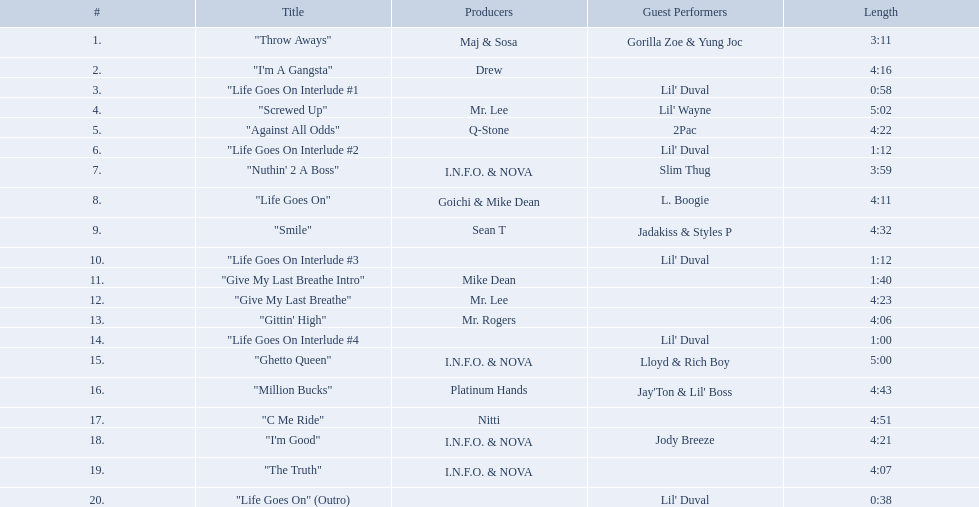What are the song lengths of all the songs on the album? 3:11, 4:16, 0:58, 5:02, 4:22, 1:12, 3:59, 4:11, 4:32, 1:12, 1:40, 4:23, 4:06, 1:00, 5:00, 4:43, 4:51, 4:21, 4:07, 0:38. Which is the longest of these? 5:02. Which tunes last longer than 4.00? "I'm A Gangsta", "Screwed Up", "Against All Odds", "Life Goes On", "Smile", "Give My Last Breathe", "Gittin' High", "Ghetto Queen", "Million Bucks", "C Me Ride", "I'm Good", "The Truth". Of those, which tunes have a duration surpassing 4.30? "Screwed Up", "Smile", "Ghetto Queen", "Million Bucks", "C Me Ride". Of those, which tunes are 5.00 or lengthier? "Screwed Up", "Ghetto Queen". Among them, which one is the most extended? "Screwed Up". How lengthy is that tune? 5:02. Which songs have a duration greater than 4.00? "I'm A Gangsta", "Screwed Up", "Against All Odds", "Life Goes On", "Smile", "Give My Last Breathe", "Gittin' High", "Ghetto Queen", "Million Bucks", "C Me Ride", "I'm Good", "The Truth". Among them, which songs exceed 4.30? "Screwed Up", "Smile", "Ghetto Queen", "Million Bucks", "C Me Ride". Among those, which songs are 5.00 or more? "Screwed Up", "Ghetto Queen". Out of those, which one has the maximum length? "Screwed Up". What is the duration of that song? 5:02. What songs are featured on the album life goes on by trae? "Throw Aways", "I'm A Gangsta", "Life Goes On Interlude #1, "Screwed Up", "Against All Odds", "Life Goes On Interlude #2, "Nuthin' 2 A Boss", "Life Goes On", "Smile", "Life Goes On Interlude #3, "Give My Last Breathe Intro", "Give My Last Breathe", "Gittin' High", "Life Goes On Interlude #4, "Ghetto Queen", "Million Bucks", "C Me Ride", "I'm Good", "The Truth", "Life Goes On" (Outro). Which of these tracks have a duration of at least 5 minutes? "Screwed Up", "Ghetto Queen". Out of the two songs that are over 5 minutes long, which one has a longer duration? "Screwed Up". What is the length of this particular song? 5:02. Parse the full table in json format. {'header': ['#', 'Title', 'Producers', 'Guest Performers', 'Length'], 'rows': [['1.', '"Throw Aways"', 'Maj & Sosa', 'Gorilla Zoe & Yung Joc', '3:11'], ['2.', '"I\'m A Gangsta"', 'Drew', '', '4:16'], ['3.', '"Life Goes On Interlude #1', '', "Lil' Duval", '0:58'], ['4.', '"Screwed Up"', 'Mr. Lee', "Lil' Wayne", '5:02'], ['5.', '"Against All Odds"', 'Q-Stone', '2Pac', '4:22'], ['6.', '"Life Goes On Interlude #2', '', "Lil' Duval", '1:12'], ['7.', '"Nuthin\' 2 A Boss"', 'I.N.F.O. & NOVA', 'Slim Thug', '3:59'], ['8.', '"Life Goes On"', 'Goichi & Mike Dean', 'L. Boogie', '4:11'], ['9.', '"Smile"', 'Sean T', 'Jadakiss & Styles P', '4:32'], ['10.', '"Life Goes On Interlude #3', '', "Lil' Duval", '1:12'], ['11.', '"Give My Last Breathe Intro"', 'Mike Dean', '', '1:40'], ['12.', '"Give My Last Breathe"', 'Mr. Lee', '', '4:23'], ['13.', '"Gittin\' High"', 'Mr. Rogers', '', '4:06'], ['14.', '"Life Goes On Interlude #4', '', "Lil' Duval", '1:00'], ['15.', '"Ghetto Queen"', 'I.N.F.O. & NOVA', 'Lloyd & Rich Boy', '5:00'], ['16.', '"Million Bucks"', 'Platinum Hands', "Jay'Ton & Lil' Boss", '4:43'], ['17.', '"C Me Ride"', 'Nitti', '', '4:51'], ['18.', '"I\'m Good"', 'I.N.F.O. & NOVA', 'Jody Breeze', '4:21'], ['19.', '"The Truth"', 'I.N.F.O. & NOVA', '', '4:07'], ['20.', '"Life Goes On" (Outro)', '', "Lil' Duval", '0:38']]} On the life goes on album by trae, which tracks are included? "Throw Aways", "I'm A Gangsta", "Life Goes On Interlude #1, "Screwed Up", "Against All Odds", "Life Goes On Interlude #2, "Nuthin' 2 A Boss", "Life Goes On", "Smile", "Life Goes On Interlude #3, "Give My Last Breathe Intro", "Give My Last Breathe", "Gittin' High", "Life Goes On Interlude #4, "Ghetto Queen", "Million Bucks", "C Me Ride", "I'm Good", "The Truth", "Life Goes On" (Outro). Among these songs, which ones last for a minimum of 5 minutes? "Screwed Up", "Ghetto Queen". From the two tracks that exceed 5 minutes in length, which one is longer? "Screwed Up". How many minutes does this song last? 5:02. Which songs can be found on trae's album life goes on? "Throw Aways", "I'm A Gangsta", "Life Goes On Interlude #1, "Screwed Up", "Against All Odds", "Life Goes On Interlude #2, "Nuthin' 2 A Boss", "Life Goes On", "Smile", "Life Goes On Interlude #3, "Give My Last Breathe Intro", "Give My Last Breathe", "Gittin' High", "Life Goes On Interlude #4, "Ghetto Queen", "Million Bucks", "C Me Ride", "I'm Good", "The Truth", "Life Goes On" (Outro). Which of these tracks have a playing time of 5 minutes or more? "Screwed Up", "Ghetto Queen". Between the two songs that are longer than 5 minutes, which one has a greater duration? "Screwed Up". What is the exact length of this track? 5:02. 